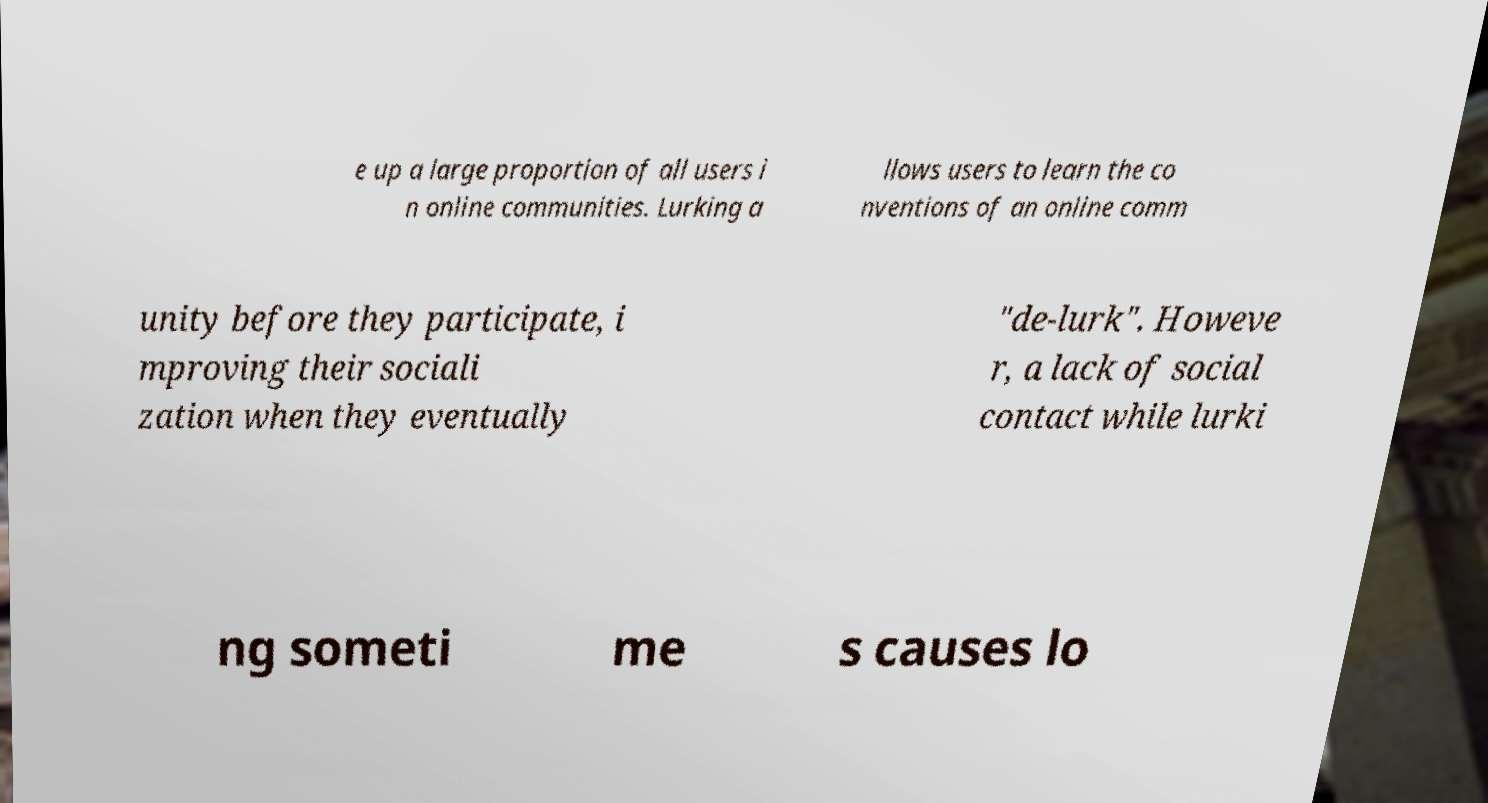I need the written content from this picture converted into text. Can you do that? e up a large proportion of all users i n online communities. Lurking a llows users to learn the co nventions of an online comm unity before they participate, i mproving their sociali zation when they eventually "de-lurk". Howeve r, a lack of social contact while lurki ng someti me s causes lo 